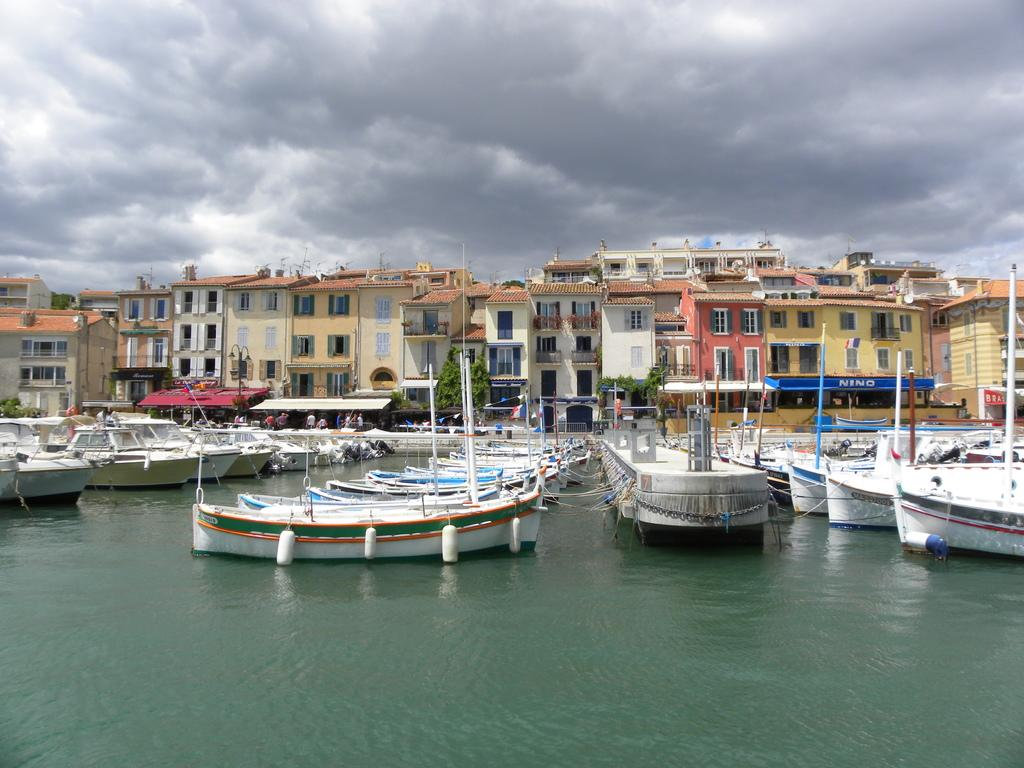What type of structures can be seen in the image? There are buildings in the image. What other natural elements are present in the image? There are trees in the image. What type of watercraft can be seen in the image? There are ships and boats in the image. Where are the ships and boats located in the image? The ships and boats are on a river in the image. What can be seen in the background of the image? The sky is visible in the background of the image. What is the purpose of the wax in the image? There is no wax present in the image, so it cannot be used for any purpose within the context of the image. 